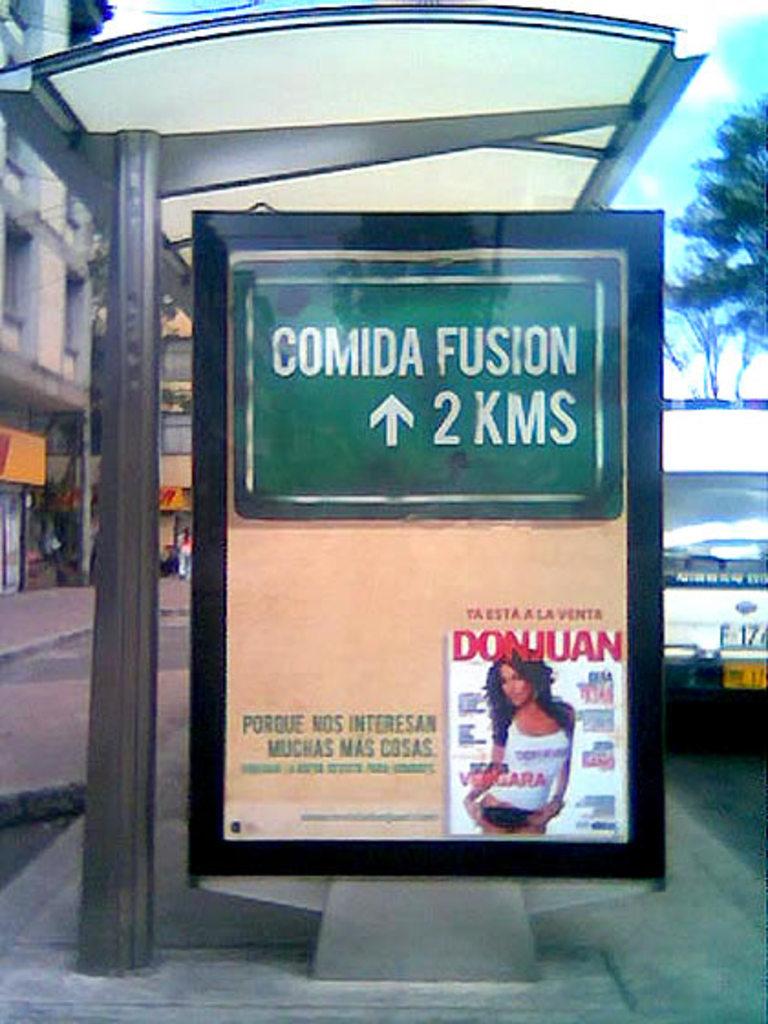Is that a lady on the sign?
Your answer should be compact. Answering does not require reading text in the image. How many kms?
Provide a succinct answer. 2. 